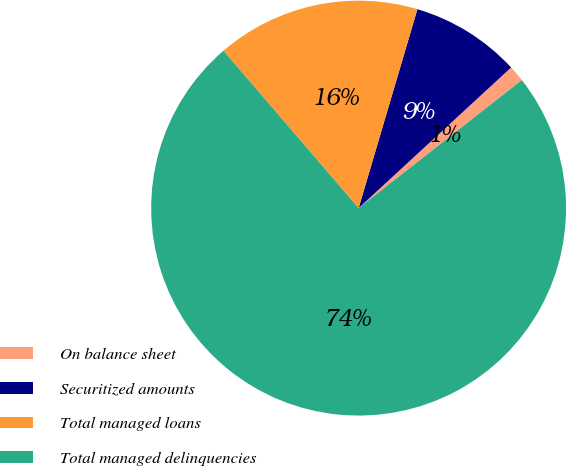Convert chart to OTSL. <chart><loc_0><loc_0><loc_500><loc_500><pie_chart><fcel>On balance sheet<fcel>Securitized amounts<fcel>Total managed loans<fcel>Total managed delinquencies<nl><fcel>1.27%<fcel>8.57%<fcel>15.87%<fcel>74.29%<nl></chart> 